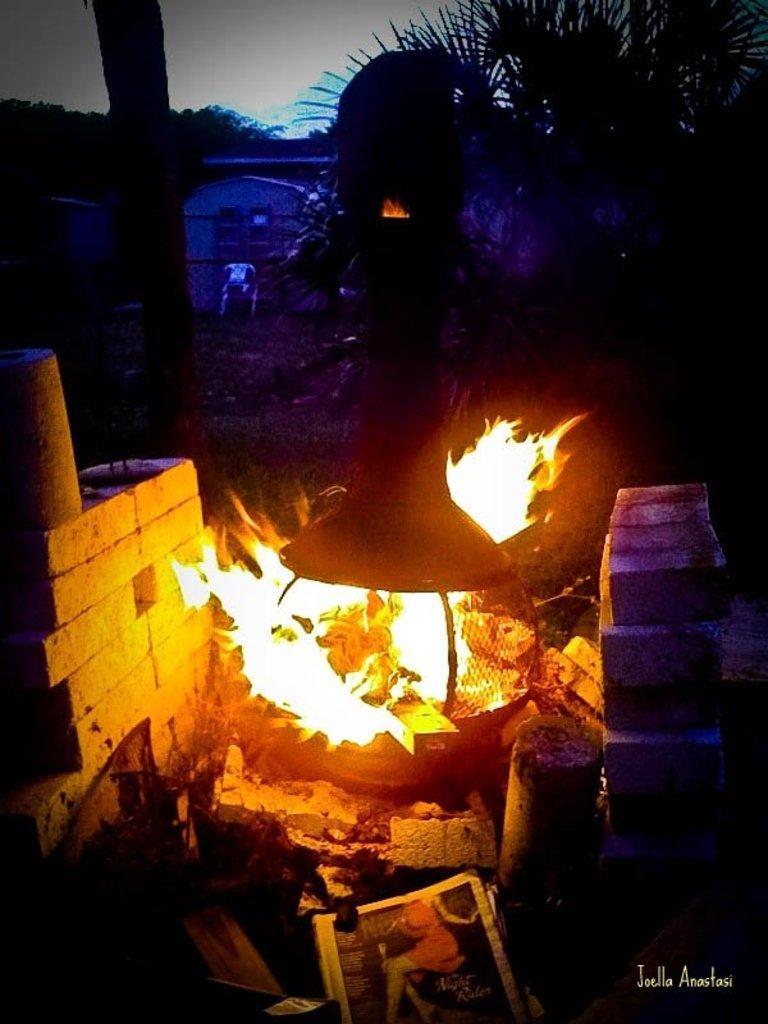Describe this image in one or two sentences. In this image in the center there is a fire. In the background there are trees, there is a chair which is white in colour. On the left side there is a wall. In the front there is a frame. 